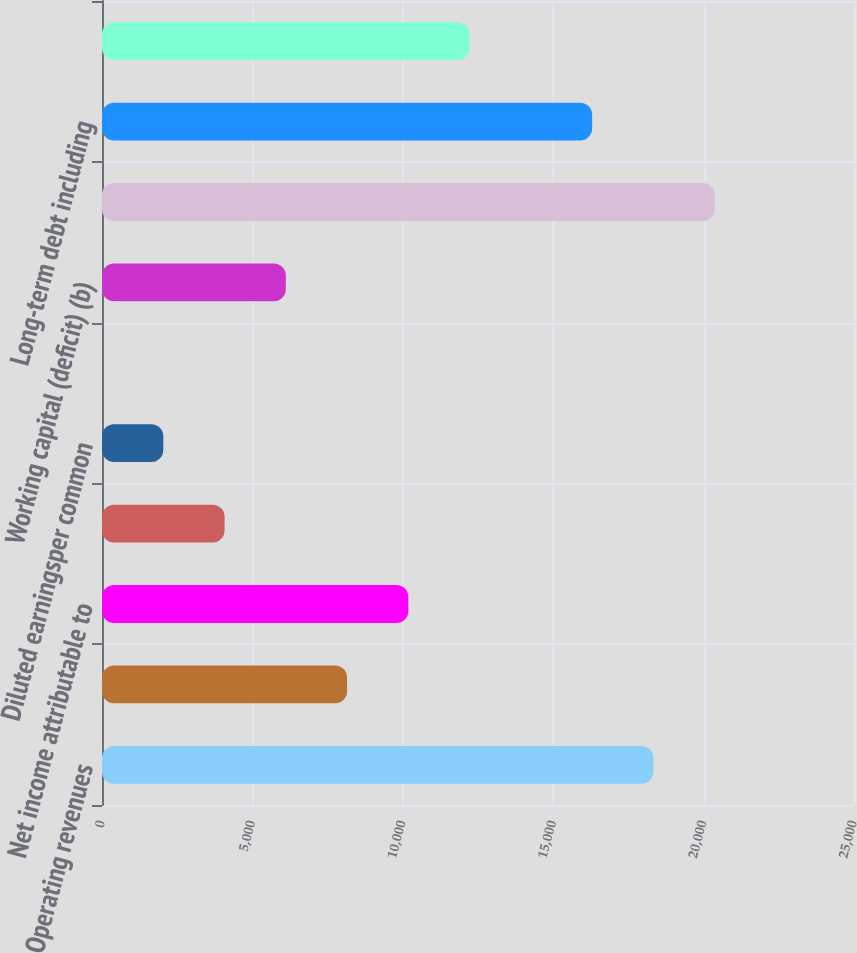Convert chart to OTSL. <chart><loc_0><loc_0><loc_500><loc_500><bar_chart><fcel>Operating revenues<fcel>Consolidated net income<fcel>Net income attributable to<fcel>Basic earningsper common share<fcel>Diluted earningsper common<fcel>Cash dividends declared per<fcel>Working capital (deficit) (b)<fcel>Total assets<fcel>Long-term debt including<fcel>Total Waste Management Inc<nl><fcel>18330.5<fcel>8147.74<fcel>10184.3<fcel>4074.64<fcel>2038.09<fcel>1.54<fcel>6111.19<fcel>20367<fcel>16293.9<fcel>12220.8<nl></chart> 